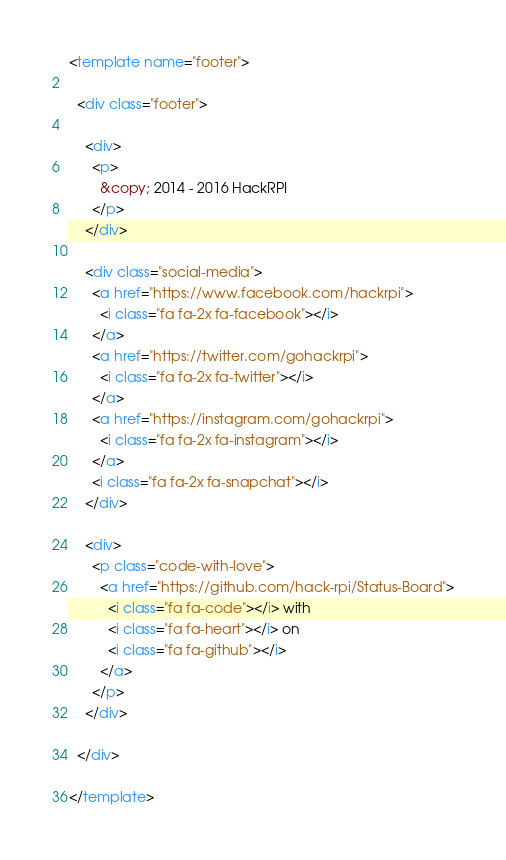<code> <loc_0><loc_0><loc_500><loc_500><_HTML_><template name="footer">

  <div class="footer">

    <div>
      <p>
        &copy; 2014 - 2016 HackRPI
      </p>
    </div>

    <div class="social-media">
      <a href="https://www.facebook.com/hackrpi">
        <i class="fa fa-2x fa-facebook"></i>
      </a>
      <a href="https://twitter.com/gohackrpi">
        <i class="fa fa-2x fa-twitter"></i>
      </a>
      <a href="https://instagram.com/gohackrpi">
        <i class="fa fa-2x fa-instagram"></i>
      </a>
      <i class="fa fa-2x fa-snapchat"></i>
    </div>

    <div>
      <p class="code-with-love">
        <a href="https://github.com/hack-rpi/Status-Board">
          <i class="fa fa-code"></i> with
          <i class="fa fa-heart"></i> on
          <i class="fa fa-github"></i>
        </a>
      </p>
    </div>

  </div>

</template>
</code> 